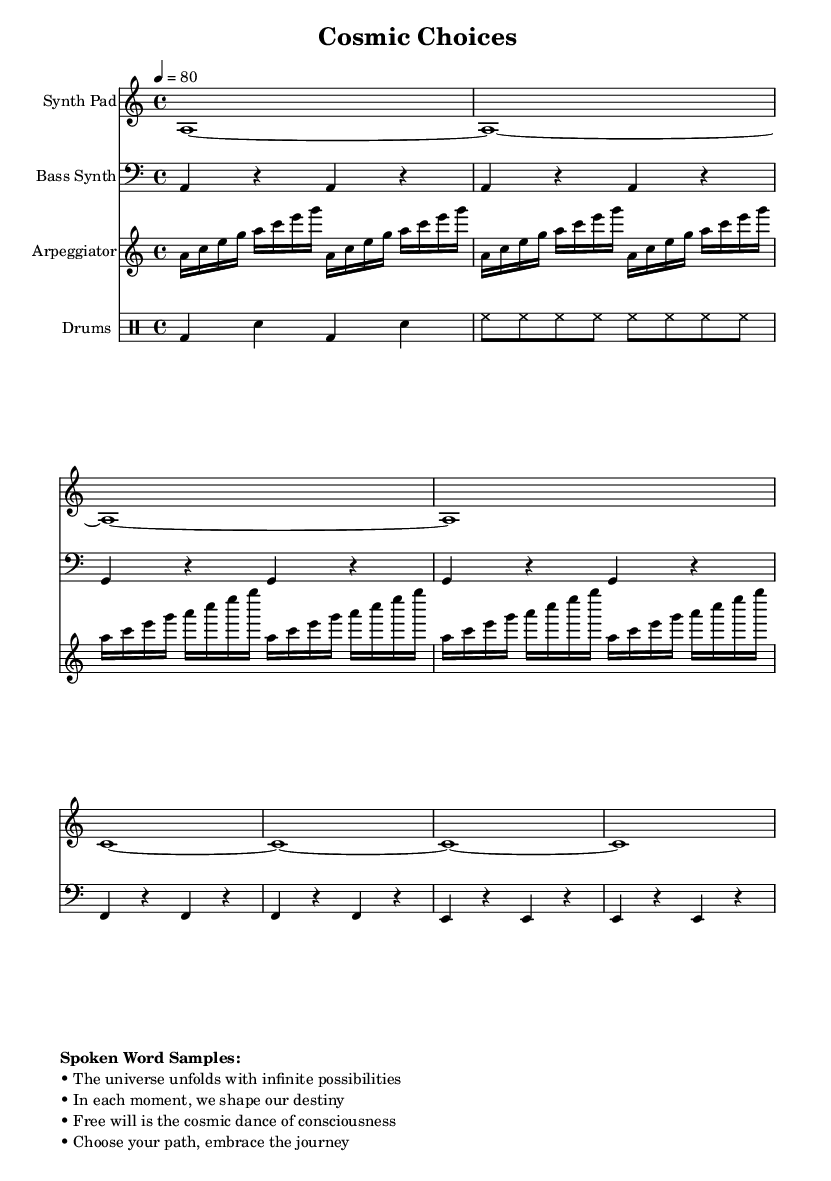What is the key signature of this music? The key signature is indicated by the "a" in the global context, meaning the music is in A minor, which has no sharps or flats.
Answer: A minor What is the time signature of the piece? The time signature is shown as "4/4" in the global context, indicating that there are four beats per measure, with each beat being a quarter note.
Answer: 4/4 What is the tempo marking of the composition? The tempo is written as "4 = 80," meaning that the quarter note should be played at a speed of 80 beats per minute, which is relatively slow for a downtempo piece.
Answer: 80 How many measures does the arpeggiator part have? The arpeggiator part is indicated with a repeated structure of 4 measures for the first section and 4 measures for the second, making a total of 8 measures in the arpeggiator.
Answer: 8 measures What type of spoken word sample is included? The spoken word samples each convey philosophical ideas about free will and consciousness, serving to enhance the downtempo electronica's deeper thematic content.
Answer: Philosophical In what style does this music fall? The combination of smooth synth pads, bass synths, and philosophical spoken word elements characterizes the piece as downtempo electronica.
Answer: Downtempo electronica What instruments are used in this composition? The score mentions a Synth Pad, Bass Synth, Arpeggiator, and Drums, highlighting the electronic nature of the arrangement.
Answer: Synth Pad, Bass Synth, Arpeggiator, Drums 